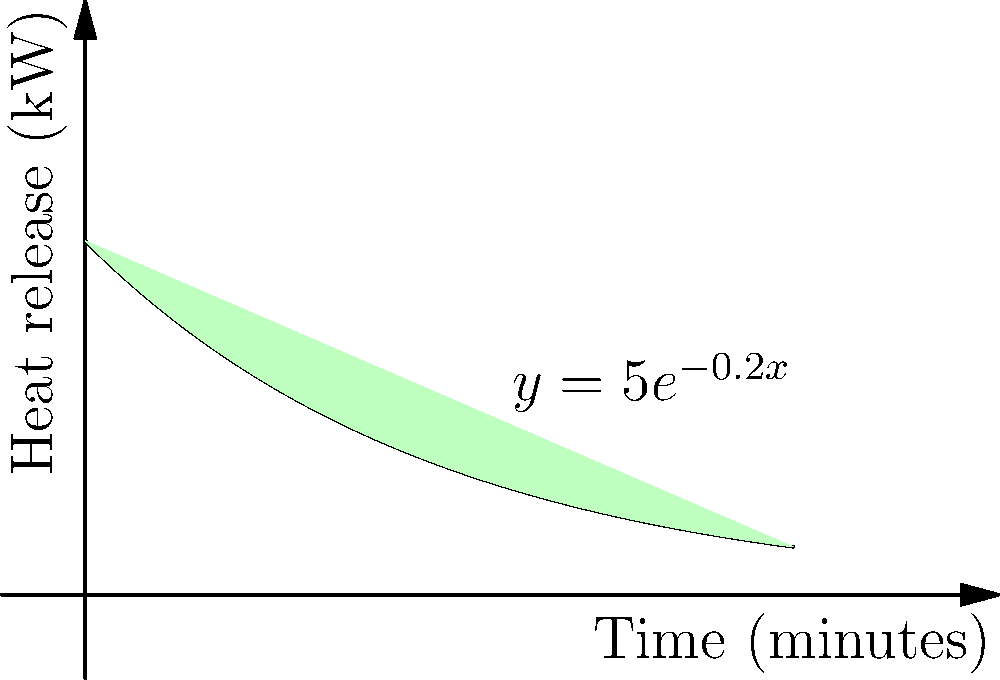In a Finnish sauna, the heat energy released by sauna stones over time can be modeled by the function $y = 5e^{-0.2x}$, where $y$ is the heat release in kilowatts and $x$ is the time in minutes. Calculate the total heat energy released over the first 10 minutes of the sauna session. Express your answer in kilojoules (kJ). To solve this problem, we need to follow these steps:

1) The total heat energy released is represented by the area under the curve from $x=0$ to $x=10$.

2) We can find this area by integrating the function from 0 to 10:

   $\int_0^{10} 5e^{-0.2x} dx$

3) To integrate this, we'll use the rule for integrating exponential functions:
   $\int e^{ax} dx = \frac{1}{a}e^{ax} + C$

4) Applying this rule to our integral:

   $5 \int_0^{10} e^{-0.2x} dx = 5 \cdot [-5e^{-0.2x}]_0^{10}$

5) Evaluating the integral:

   $= 5 \cdot [-5e^{-0.2 \cdot 10} - (-5e^{-0.2 \cdot 0})]$
   $= 5 \cdot [-5e^{-2} - (-5)]$
   $= 5 \cdot [-5 \cdot 0.1353 + 5]$
   $= 5 \cdot [4.3235]$
   $= 21.6175$

6) This result is in kilowatt-minutes. To convert to kilojoules:
   
   $21.6175 \text{ kW-min} \cdot \frac{60 \text{ s}}{1 \text{ min}} = 1297.05 \text{ kJ}$

Therefore, the total heat energy released over the first 10 minutes is approximately 1297.05 kJ.
Answer: 1297.05 kJ 